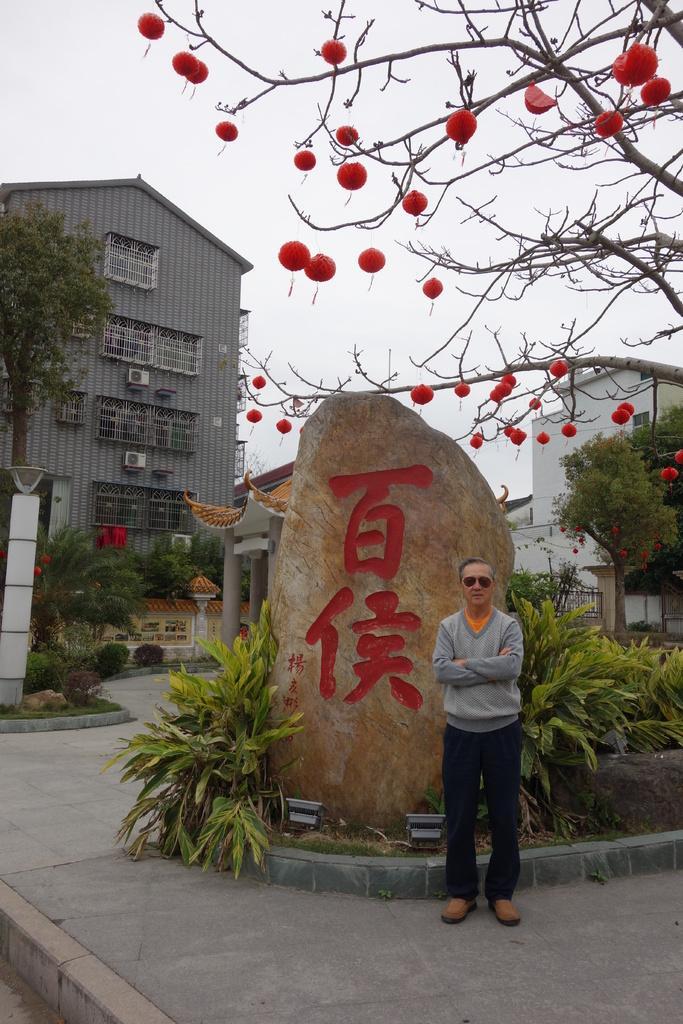Could you give a brief overview of what you see in this image? This image consists of a man standing on the road. Behind him, there is a stone. On which there is text. In the background, there is a building. To the right, there is a tree along with the fruits. 